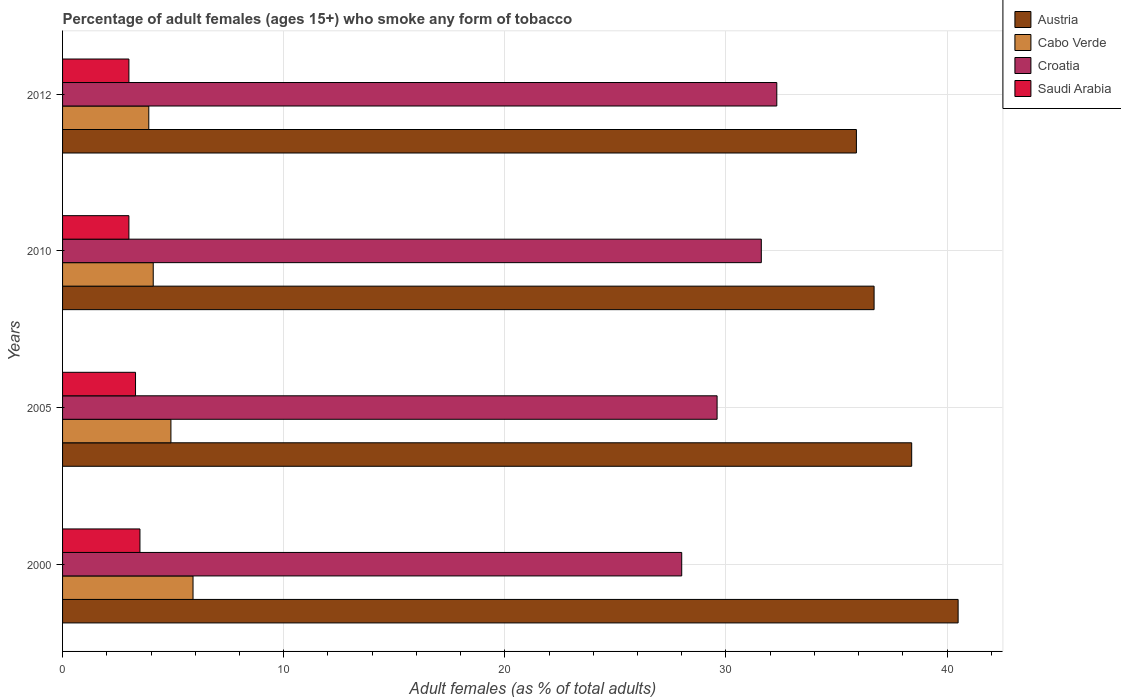Are the number of bars per tick equal to the number of legend labels?
Offer a very short reply. Yes. How many bars are there on the 2nd tick from the bottom?
Keep it short and to the point. 4. In how many cases, is the number of bars for a given year not equal to the number of legend labels?
Keep it short and to the point. 0. Across all years, what is the maximum percentage of adult females who smoke in Austria?
Make the answer very short. 40.5. Across all years, what is the minimum percentage of adult females who smoke in Croatia?
Your answer should be very brief. 28. In which year was the percentage of adult females who smoke in Saudi Arabia maximum?
Make the answer very short. 2000. What is the difference between the percentage of adult females who smoke in Cabo Verde in 2000 and that in 2012?
Keep it short and to the point. 2. What is the difference between the percentage of adult females who smoke in Cabo Verde in 2010 and the percentage of adult females who smoke in Austria in 2000?
Make the answer very short. -36.4. What is the average percentage of adult females who smoke in Cabo Verde per year?
Your response must be concise. 4.7. In the year 2012, what is the difference between the percentage of adult females who smoke in Croatia and percentage of adult females who smoke in Saudi Arabia?
Your answer should be compact. 29.3. In how many years, is the percentage of adult females who smoke in Croatia greater than 26 %?
Your answer should be very brief. 4. What is the ratio of the percentage of adult females who smoke in Saudi Arabia in 2005 to that in 2010?
Offer a terse response. 1.1. Is the percentage of adult females who smoke in Austria in 2000 less than that in 2010?
Your answer should be compact. No. Is the difference between the percentage of adult females who smoke in Croatia in 2000 and 2005 greater than the difference between the percentage of adult females who smoke in Saudi Arabia in 2000 and 2005?
Keep it short and to the point. No. What is the difference between the highest and the second highest percentage of adult females who smoke in Austria?
Ensure brevity in your answer.  2.1. What is the difference between the highest and the lowest percentage of adult females who smoke in Croatia?
Your response must be concise. 4.3. Is it the case that in every year, the sum of the percentage of adult females who smoke in Saudi Arabia and percentage of adult females who smoke in Croatia is greater than the sum of percentage of adult females who smoke in Austria and percentage of adult females who smoke in Cabo Verde?
Provide a succinct answer. Yes. What does the 3rd bar from the top in 2005 represents?
Offer a terse response. Cabo Verde. What does the 1st bar from the bottom in 2010 represents?
Offer a very short reply. Austria. Is it the case that in every year, the sum of the percentage of adult females who smoke in Austria and percentage of adult females who smoke in Cabo Verde is greater than the percentage of adult females who smoke in Croatia?
Offer a terse response. Yes. What is the difference between two consecutive major ticks on the X-axis?
Make the answer very short. 10. Does the graph contain any zero values?
Your response must be concise. No. How many legend labels are there?
Provide a succinct answer. 4. What is the title of the graph?
Offer a terse response. Percentage of adult females (ages 15+) who smoke any form of tobacco. Does "Mauritius" appear as one of the legend labels in the graph?
Offer a very short reply. No. What is the label or title of the X-axis?
Provide a short and direct response. Adult females (as % of total adults). What is the Adult females (as % of total adults) in Austria in 2000?
Provide a short and direct response. 40.5. What is the Adult females (as % of total adults) in Croatia in 2000?
Your answer should be very brief. 28. What is the Adult females (as % of total adults) of Austria in 2005?
Provide a succinct answer. 38.4. What is the Adult females (as % of total adults) of Cabo Verde in 2005?
Give a very brief answer. 4.9. What is the Adult females (as % of total adults) in Croatia in 2005?
Give a very brief answer. 29.6. What is the Adult females (as % of total adults) in Saudi Arabia in 2005?
Your answer should be very brief. 3.3. What is the Adult females (as % of total adults) of Austria in 2010?
Provide a succinct answer. 36.7. What is the Adult females (as % of total adults) of Cabo Verde in 2010?
Keep it short and to the point. 4.1. What is the Adult females (as % of total adults) in Croatia in 2010?
Offer a very short reply. 31.6. What is the Adult females (as % of total adults) in Saudi Arabia in 2010?
Offer a very short reply. 3. What is the Adult females (as % of total adults) in Austria in 2012?
Provide a succinct answer. 35.9. What is the Adult females (as % of total adults) in Cabo Verde in 2012?
Provide a succinct answer. 3.9. What is the Adult females (as % of total adults) in Croatia in 2012?
Give a very brief answer. 32.3. Across all years, what is the maximum Adult females (as % of total adults) in Austria?
Offer a terse response. 40.5. Across all years, what is the maximum Adult females (as % of total adults) of Croatia?
Make the answer very short. 32.3. Across all years, what is the minimum Adult females (as % of total adults) of Austria?
Your answer should be very brief. 35.9. Across all years, what is the minimum Adult females (as % of total adults) in Cabo Verde?
Provide a succinct answer. 3.9. Across all years, what is the minimum Adult females (as % of total adults) in Saudi Arabia?
Provide a succinct answer. 3. What is the total Adult females (as % of total adults) in Austria in the graph?
Make the answer very short. 151.5. What is the total Adult females (as % of total adults) of Cabo Verde in the graph?
Provide a succinct answer. 18.8. What is the total Adult females (as % of total adults) in Croatia in the graph?
Offer a terse response. 121.5. What is the difference between the Adult females (as % of total adults) of Austria in 2000 and that in 2005?
Provide a succinct answer. 2.1. What is the difference between the Adult females (as % of total adults) in Cabo Verde in 2000 and that in 2005?
Give a very brief answer. 1. What is the difference between the Adult females (as % of total adults) in Croatia in 2000 and that in 2005?
Keep it short and to the point. -1.6. What is the difference between the Adult females (as % of total adults) of Saudi Arabia in 2000 and that in 2005?
Provide a short and direct response. 0.2. What is the difference between the Adult females (as % of total adults) of Austria in 2000 and that in 2010?
Ensure brevity in your answer.  3.8. What is the difference between the Adult females (as % of total adults) in Cabo Verde in 2000 and that in 2010?
Keep it short and to the point. 1.8. What is the difference between the Adult females (as % of total adults) in Austria in 2000 and that in 2012?
Your answer should be compact. 4.6. What is the difference between the Adult females (as % of total adults) of Croatia in 2000 and that in 2012?
Offer a terse response. -4.3. What is the difference between the Adult females (as % of total adults) in Saudi Arabia in 2000 and that in 2012?
Offer a very short reply. 0.5. What is the difference between the Adult females (as % of total adults) in Saudi Arabia in 2005 and that in 2010?
Ensure brevity in your answer.  0.3. What is the difference between the Adult females (as % of total adults) of Saudi Arabia in 2005 and that in 2012?
Make the answer very short. 0.3. What is the difference between the Adult females (as % of total adults) in Cabo Verde in 2010 and that in 2012?
Offer a terse response. 0.2. What is the difference between the Adult females (as % of total adults) of Croatia in 2010 and that in 2012?
Offer a very short reply. -0.7. What is the difference between the Adult females (as % of total adults) of Saudi Arabia in 2010 and that in 2012?
Your answer should be very brief. 0. What is the difference between the Adult females (as % of total adults) of Austria in 2000 and the Adult females (as % of total adults) of Cabo Verde in 2005?
Offer a terse response. 35.6. What is the difference between the Adult females (as % of total adults) in Austria in 2000 and the Adult females (as % of total adults) in Saudi Arabia in 2005?
Ensure brevity in your answer.  37.2. What is the difference between the Adult females (as % of total adults) of Cabo Verde in 2000 and the Adult females (as % of total adults) of Croatia in 2005?
Keep it short and to the point. -23.7. What is the difference between the Adult females (as % of total adults) in Cabo Verde in 2000 and the Adult females (as % of total adults) in Saudi Arabia in 2005?
Provide a succinct answer. 2.6. What is the difference between the Adult females (as % of total adults) in Croatia in 2000 and the Adult females (as % of total adults) in Saudi Arabia in 2005?
Offer a terse response. 24.7. What is the difference between the Adult females (as % of total adults) of Austria in 2000 and the Adult females (as % of total adults) of Cabo Verde in 2010?
Provide a short and direct response. 36.4. What is the difference between the Adult females (as % of total adults) in Austria in 2000 and the Adult females (as % of total adults) in Saudi Arabia in 2010?
Keep it short and to the point. 37.5. What is the difference between the Adult females (as % of total adults) of Cabo Verde in 2000 and the Adult females (as % of total adults) of Croatia in 2010?
Provide a succinct answer. -25.7. What is the difference between the Adult females (as % of total adults) of Croatia in 2000 and the Adult females (as % of total adults) of Saudi Arabia in 2010?
Make the answer very short. 25. What is the difference between the Adult females (as % of total adults) in Austria in 2000 and the Adult females (as % of total adults) in Cabo Verde in 2012?
Provide a succinct answer. 36.6. What is the difference between the Adult females (as % of total adults) in Austria in 2000 and the Adult females (as % of total adults) in Croatia in 2012?
Your answer should be very brief. 8.2. What is the difference between the Adult females (as % of total adults) in Austria in 2000 and the Adult females (as % of total adults) in Saudi Arabia in 2012?
Your response must be concise. 37.5. What is the difference between the Adult females (as % of total adults) of Cabo Verde in 2000 and the Adult females (as % of total adults) of Croatia in 2012?
Offer a very short reply. -26.4. What is the difference between the Adult females (as % of total adults) in Croatia in 2000 and the Adult females (as % of total adults) in Saudi Arabia in 2012?
Make the answer very short. 25. What is the difference between the Adult females (as % of total adults) of Austria in 2005 and the Adult females (as % of total adults) of Cabo Verde in 2010?
Give a very brief answer. 34.3. What is the difference between the Adult females (as % of total adults) in Austria in 2005 and the Adult females (as % of total adults) in Croatia in 2010?
Provide a succinct answer. 6.8. What is the difference between the Adult females (as % of total adults) of Austria in 2005 and the Adult females (as % of total adults) of Saudi Arabia in 2010?
Provide a succinct answer. 35.4. What is the difference between the Adult females (as % of total adults) in Cabo Verde in 2005 and the Adult females (as % of total adults) in Croatia in 2010?
Provide a short and direct response. -26.7. What is the difference between the Adult females (as % of total adults) in Cabo Verde in 2005 and the Adult females (as % of total adults) in Saudi Arabia in 2010?
Your response must be concise. 1.9. What is the difference between the Adult females (as % of total adults) of Croatia in 2005 and the Adult females (as % of total adults) of Saudi Arabia in 2010?
Provide a short and direct response. 26.6. What is the difference between the Adult females (as % of total adults) in Austria in 2005 and the Adult females (as % of total adults) in Cabo Verde in 2012?
Give a very brief answer. 34.5. What is the difference between the Adult females (as % of total adults) in Austria in 2005 and the Adult females (as % of total adults) in Croatia in 2012?
Ensure brevity in your answer.  6.1. What is the difference between the Adult females (as % of total adults) of Austria in 2005 and the Adult females (as % of total adults) of Saudi Arabia in 2012?
Your answer should be very brief. 35.4. What is the difference between the Adult females (as % of total adults) in Cabo Verde in 2005 and the Adult females (as % of total adults) in Croatia in 2012?
Provide a short and direct response. -27.4. What is the difference between the Adult females (as % of total adults) of Croatia in 2005 and the Adult females (as % of total adults) of Saudi Arabia in 2012?
Ensure brevity in your answer.  26.6. What is the difference between the Adult females (as % of total adults) in Austria in 2010 and the Adult females (as % of total adults) in Cabo Verde in 2012?
Your answer should be very brief. 32.8. What is the difference between the Adult females (as % of total adults) of Austria in 2010 and the Adult females (as % of total adults) of Saudi Arabia in 2012?
Ensure brevity in your answer.  33.7. What is the difference between the Adult females (as % of total adults) in Cabo Verde in 2010 and the Adult females (as % of total adults) in Croatia in 2012?
Your answer should be compact. -28.2. What is the difference between the Adult females (as % of total adults) of Croatia in 2010 and the Adult females (as % of total adults) of Saudi Arabia in 2012?
Offer a terse response. 28.6. What is the average Adult females (as % of total adults) of Austria per year?
Ensure brevity in your answer.  37.88. What is the average Adult females (as % of total adults) in Croatia per year?
Provide a succinct answer. 30.38. What is the average Adult females (as % of total adults) in Saudi Arabia per year?
Ensure brevity in your answer.  3.2. In the year 2000, what is the difference between the Adult females (as % of total adults) in Austria and Adult females (as % of total adults) in Cabo Verde?
Offer a terse response. 34.6. In the year 2000, what is the difference between the Adult females (as % of total adults) in Cabo Verde and Adult females (as % of total adults) in Croatia?
Offer a terse response. -22.1. In the year 2005, what is the difference between the Adult females (as % of total adults) of Austria and Adult females (as % of total adults) of Cabo Verde?
Your response must be concise. 33.5. In the year 2005, what is the difference between the Adult females (as % of total adults) in Austria and Adult females (as % of total adults) in Saudi Arabia?
Your response must be concise. 35.1. In the year 2005, what is the difference between the Adult females (as % of total adults) of Cabo Verde and Adult females (as % of total adults) of Croatia?
Your answer should be very brief. -24.7. In the year 2005, what is the difference between the Adult females (as % of total adults) in Cabo Verde and Adult females (as % of total adults) in Saudi Arabia?
Ensure brevity in your answer.  1.6. In the year 2005, what is the difference between the Adult females (as % of total adults) of Croatia and Adult females (as % of total adults) of Saudi Arabia?
Offer a terse response. 26.3. In the year 2010, what is the difference between the Adult females (as % of total adults) of Austria and Adult females (as % of total adults) of Cabo Verde?
Offer a terse response. 32.6. In the year 2010, what is the difference between the Adult females (as % of total adults) in Austria and Adult females (as % of total adults) in Saudi Arabia?
Keep it short and to the point. 33.7. In the year 2010, what is the difference between the Adult females (as % of total adults) in Cabo Verde and Adult females (as % of total adults) in Croatia?
Your response must be concise. -27.5. In the year 2010, what is the difference between the Adult females (as % of total adults) in Cabo Verde and Adult females (as % of total adults) in Saudi Arabia?
Provide a succinct answer. 1.1. In the year 2010, what is the difference between the Adult females (as % of total adults) of Croatia and Adult females (as % of total adults) of Saudi Arabia?
Ensure brevity in your answer.  28.6. In the year 2012, what is the difference between the Adult females (as % of total adults) in Austria and Adult females (as % of total adults) in Saudi Arabia?
Offer a very short reply. 32.9. In the year 2012, what is the difference between the Adult females (as % of total adults) in Cabo Verde and Adult females (as % of total adults) in Croatia?
Your answer should be compact. -28.4. In the year 2012, what is the difference between the Adult females (as % of total adults) in Croatia and Adult females (as % of total adults) in Saudi Arabia?
Offer a terse response. 29.3. What is the ratio of the Adult females (as % of total adults) of Austria in 2000 to that in 2005?
Provide a succinct answer. 1.05. What is the ratio of the Adult females (as % of total adults) in Cabo Verde in 2000 to that in 2005?
Your answer should be very brief. 1.2. What is the ratio of the Adult females (as % of total adults) in Croatia in 2000 to that in 2005?
Keep it short and to the point. 0.95. What is the ratio of the Adult females (as % of total adults) in Saudi Arabia in 2000 to that in 2005?
Your answer should be very brief. 1.06. What is the ratio of the Adult females (as % of total adults) in Austria in 2000 to that in 2010?
Make the answer very short. 1.1. What is the ratio of the Adult females (as % of total adults) of Cabo Verde in 2000 to that in 2010?
Make the answer very short. 1.44. What is the ratio of the Adult females (as % of total adults) in Croatia in 2000 to that in 2010?
Give a very brief answer. 0.89. What is the ratio of the Adult females (as % of total adults) in Austria in 2000 to that in 2012?
Your answer should be compact. 1.13. What is the ratio of the Adult females (as % of total adults) of Cabo Verde in 2000 to that in 2012?
Your response must be concise. 1.51. What is the ratio of the Adult females (as % of total adults) in Croatia in 2000 to that in 2012?
Your answer should be compact. 0.87. What is the ratio of the Adult females (as % of total adults) of Saudi Arabia in 2000 to that in 2012?
Give a very brief answer. 1.17. What is the ratio of the Adult females (as % of total adults) of Austria in 2005 to that in 2010?
Your response must be concise. 1.05. What is the ratio of the Adult females (as % of total adults) of Cabo Verde in 2005 to that in 2010?
Your answer should be compact. 1.2. What is the ratio of the Adult females (as % of total adults) of Croatia in 2005 to that in 2010?
Keep it short and to the point. 0.94. What is the ratio of the Adult females (as % of total adults) of Saudi Arabia in 2005 to that in 2010?
Keep it short and to the point. 1.1. What is the ratio of the Adult females (as % of total adults) in Austria in 2005 to that in 2012?
Provide a succinct answer. 1.07. What is the ratio of the Adult females (as % of total adults) of Cabo Verde in 2005 to that in 2012?
Keep it short and to the point. 1.26. What is the ratio of the Adult females (as % of total adults) in Croatia in 2005 to that in 2012?
Your answer should be very brief. 0.92. What is the ratio of the Adult females (as % of total adults) of Austria in 2010 to that in 2012?
Make the answer very short. 1.02. What is the ratio of the Adult females (as % of total adults) of Cabo Verde in 2010 to that in 2012?
Your answer should be very brief. 1.05. What is the ratio of the Adult females (as % of total adults) in Croatia in 2010 to that in 2012?
Your response must be concise. 0.98. What is the difference between the highest and the second highest Adult females (as % of total adults) of Austria?
Give a very brief answer. 2.1. What is the difference between the highest and the second highest Adult females (as % of total adults) in Cabo Verde?
Ensure brevity in your answer.  1. What is the difference between the highest and the second highest Adult females (as % of total adults) of Croatia?
Your answer should be compact. 0.7. What is the difference between the highest and the lowest Adult females (as % of total adults) of Austria?
Your answer should be compact. 4.6. What is the difference between the highest and the lowest Adult females (as % of total adults) in Saudi Arabia?
Make the answer very short. 0.5. 